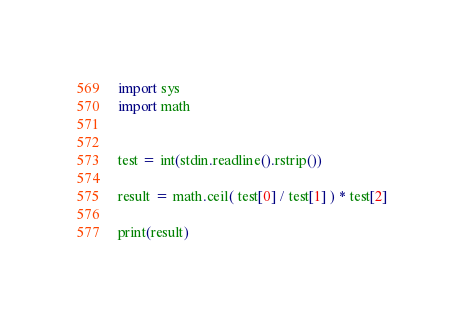Convert code to text. <code><loc_0><loc_0><loc_500><loc_500><_Python_>import sys
import math


test = int(stdin.readline().rstrip())

result = math.ceil( test[0] / test[1] ) * test[2]

print(result)</code> 